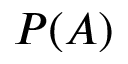<formula> <loc_0><loc_0><loc_500><loc_500>P ( A )</formula> 